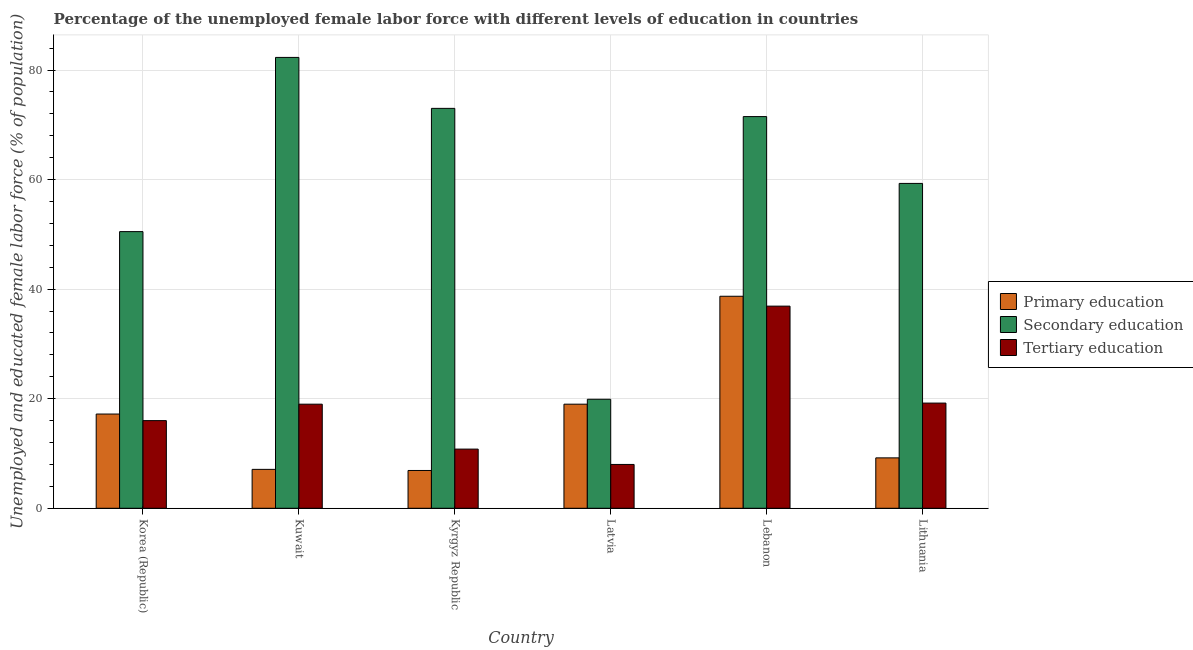How many different coloured bars are there?
Your answer should be compact. 3. Are the number of bars per tick equal to the number of legend labels?
Your answer should be very brief. Yes. How many bars are there on the 3rd tick from the right?
Provide a succinct answer. 3. What is the label of the 2nd group of bars from the left?
Ensure brevity in your answer.  Kuwait. In how many cases, is the number of bars for a given country not equal to the number of legend labels?
Your response must be concise. 0. What is the percentage of female labor force who received secondary education in Lebanon?
Ensure brevity in your answer.  71.5. Across all countries, what is the maximum percentage of female labor force who received primary education?
Your answer should be compact. 38.7. Across all countries, what is the minimum percentage of female labor force who received tertiary education?
Make the answer very short. 8. In which country was the percentage of female labor force who received primary education maximum?
Keep it short and to the point. Lebanon. In which country was the percentage of female labor force who received primary education minimum?
Your answer should be very brief. Kyrgyz Republic. What is the total percentage of female labor force who received tertiary education in the graph?
Provide a succinct answer. 109.9. What is the difference between the percentage of female labor force who received primary education in Kuwait and that in Kyrgyz Republic?
Your response must be concise. 0.2. What is the difference between the percentage of female labor force who received primary education in Lebanon and the percentage of female labor force who received tertiary education in Latvia?
Your answer should be very brief. 30.7. What is the average percentage of female labor force who received primary education per country?
Give a very brief answer. 16.35. What is the difference between the percentage of female labor force who received tertiary education and percentage of female labor force who received primary education in Kuwait?
Your answer should be compact. 11.9. What is the ratio of the percentage of female labor force who received secondary education in Kuwait to that in Lithuania?
Your answer should be very brief. 1.39. Is the difference between the percentage of female labor force who received primary education in Latvia and Lebanon greater than the difference between the percentage of female labor force who received tertiary education in Latvia and Lebanon?
Keep it short and to the point. Yes. What is the difference between the highest and the second highest percentage of female labor force who received primary education?
Provide a succinct answer. 19.7. What is the difference between the highest and the lowest percentage of female labor force who received tertiary education?
Make the answer very short. 28.9. What does the 3rd bar from the right in Kyrgyz Republic represents?
Offer a terse response. Primary education. Is it the case that in every country, the sum of the percentage of female labor force who received primary education and percentage of female labor force who received secondary education is greater than the percentage of female labor force who received tertiary education?
Make the answer very short. Yes. What is the difference between two consecutive major ticks on the Y-axis?
Offer a very short reply. 20. Are the values on the major ticks of Y-axis written in scientific E-notation?
Make the answer very short. No. Does the graph contain any zero values?
Your answer should be compact. No. Where does the legend appear in the graph?
Offer a very short reply. Center right. How many legend labels are there?
Offer a very short reply. 3. How are the legend labels stacked?
Give a very brief answer. Vertical. What is the title of the graph?
Provide a succinct answer. Percentage of the unemployed female labor force with different levels of education in countries. Does "Food" appear as one of the legend labels in the graph?
Offer a very short reply. No. What is the label or title of the Y-axis?
Ensure brevity in your answer.  Unemployed and educated female labor force (% of population). What is the Unemployed and educated female labor force (% of population) of Primary education in Korea (Republic)?
Your answer should be compact. 17.2. What is the Unemployed and educated female labor force (% of population) in Secondary education in Korea (Republic)?
Provide a short and direct response. 50.5. What is the Unemployed and educated female labor force (% of population) of Primary education in Kuwait?
Give a very brief answer. 7.1. What is the Unemployed and educated female labor force (% of population) in Secondary education in Kuwait?
Offer a terse response. 82.3. What is the Unemployed and educated female labor force (% of population) of Primary education in Kyrgyz Republic?
Offer a terse response. 6.9. What is the Unemployed and educated female labor force (% of population) of Tertiary education in Kyrgyz Republic?
Keep it short and to the point. 10.8. What is the Unemployed and educated female labor force (% of population) of Secondary education in Latvia?
Ensure brevity in your answer.  19.9. What is the Unemployed and educated female labor force (% of population) of Tertiary education in Latvia?
Offer a terse response. 8. What is the Unemployed and educated female labor force (% of population) in Primary education in Lebanon?
Provide a short and direct response. 38.7. What is the Unemployed and educated female labor force (% of population) of Secondary education in Lebanon?
Your response must be concise. 71.5. What is the Unemployed and educated female labor force (% of population) in Tertiary education in Lebanon?
Ensure brevity in your answer.  36.9. What is the Unemployed and educated female labor force (% of population) of Primary education in Lithuania?
Provide a succinct answer. 9.2. What is the Unemployed and educated female labor force (% of population) of Secondary education in Lithuania?
Provide a succinct answer. 59.3. What is the Unemployed and educated female labor force (% of population) of Tertiary education in Lithuania?
Ensure brevity in your answer.  19.2. Across all countries, what is the maximum Unemployed and educated female labor force (% of population) in Primary education?
Provide a short and direct response. 38.7. Across all countries, what is the maximum Unemployed and educated female labor force (% of population) of Secondary education?
Provide a succinct answer. 82.3. Across all countries, what is the maximum Unemployed and educated female labor force (% of population) of Tertiary education?
Ensure brevity in your answer.  36.9. Across all countries, what is the minimum Unemployed and educated female labor force (% of population) of Primary education?
Offer a terse response. 6.9. Across all countries, what is the minimum Unemployed and educated female labor force (% of population) of Secondary education?
Offer a terse response. 19.9. Across all countries, what is the minimum Unemployed and educated female labor force (% of population) in Tertiary education?
Your answer should be very brief. 8. What is the total Unemployed and educated female labor force (% of population) in Primary education in the graph?
Provide a short and direct response. 98.1. What is the total Unemployed and educated female labor force (% of population) of Secondary education in the graph?
Offer a very short reply. 356.5. What is the total Unemployed and educated female labor force (% of population) in Tertiary education in the graph?
Keep it short and to the point. 109.9. What is the difference between the Unemployed and educated female labor force (% of population) of Primary education in Korea (Republic) and that in Kuwait?
Your response must be concise. 10.1. What is the difference between the Unemployed and educated female labor force (% of population) in Secondary education in Korea (Republic) and that in Kuwait?
Provide a succinct answer. -31.8. What is the difference between the Unemployed and educated female labor force (% of population) in Primary education in Korea (Republic) and that in Kyrgyz Republic?
Make the answer very short. 10.3. What is the difference between the Unemployed and educated female labor force (% of population) of Secondary education in Korea (Republic) and that in Kyrgyz Republic?
Provide a succinct answer. -22.5. What is the difference between the Unemployed and educated female labor force (% of population) in Tertiary education in Korea (Republic) and that in Kyrgyz Republic?
Ensure brevity in your answer.  5.2. What is the difference between the Unemployed and educated female labor force (% of population) in Primary education in Korea (Republic) and that in Latvia?
Your answer should be compact. -1.8. What is the difference between the Unemployed and educated female labor force (% of population) of Secondary education in Korea (Republic) and that in Latvia?
Offer a very short reply. 30.6. What is the difference between the Unemployed and educated female labor force (% of population) of Tertiary education in Korea (Republic) and that in Latvia?
Make the answer very short. 8. What is the difference between the Unemployed and educated female labor force (% of population) in Primary education in Korea (Republic) and that in Lebanon?
Your answer should be compact. -21.5. What is the difference between the Unemployed and educated female labor force (% of population) in Secondary education in Korea (Republic) and that in Lebanon?
Your answer should be compact. -21. What is the difference between the Unemployed and educated female labor force (% of population) of Tertiary education in Korea (Republic) and that in Lebanon?
Offer a very short reply. -20.9. What is the difference between the Unemployed and educated female labor force (% of population) of Secondary education in Korea (Republic) and that in Lithuania?
Ensure brevity in your answer.  -8.8. What is the difference between the Unemployed and educated female labor force (% of population) in Tertiary education in Korea (Republic) and that in Lithuania?
Ensure brevity in your answer.  -3.2. What is the difference between the Unemployed and educated female labor force (% of population) in Tertiary education in Kuwait and that in Kyrgyz Republic?
Provide a succinct answer. 8.2. What is the difference between the Unemployed and educated female labor force (% of population) of Primary education in Kuwait and that in Latvia?
Offer a terse response. -11.9. What is the difference between the Unemployed and educated female labor force (% of population) of Secondary education in Kuwait and that in Latvia?
Offer a terse response. 62.4. What is the difference between the Unemployed and educated female labor force (% of population) of Tertiary education in Kuwait and that in Latvia?
Your answer should be very brief. 11. What is the difference between the Unemployed and educated female labor force (% of population) of Primary education in Kuwait and that in Lebanon?
Your response must be concise. -31.6. What is the difference between the Unemployed and educated female labor force (% of population) in Tertiary education in Kuwait and that in Lebanon?
Give a very brief answer. -17.9. What is the difference between the Unemployed and educated female labor force (% of population) in Primary education in Kuwait and that in Lithuania?
Provide a short and direct response. -2.1. What is the difference between the Unemployed and educated female labor force (% of population) in Secondary education in Kuwait and that in Lithuania?
Your answer should be very brief. 23. What is the difference between the Unemployed and educated female labor force (% of population) in Tertiary education in Kuwait and that in Lithuania?
Your response must be concise. -0.2. What is the difference between the Unemployed and educated female labor force (% of population) of Secondary education in Kyrgyz Republic and that in Latvia?
Ensure brevity in your answer.  53.1. What is the difference between the Unemployed and educated female labor force (% of population) of Tertiary education in Kyrgyz Republic and that in Latvia?
Ensure brevity in your answer.  2.8. What is the difference between the Unemployed and educated female labor force (% of population) in Primary education in Kyrgyz Republic and that in Lebanon?
Your answer should be very brief. -31.8. What is the difference between the Unemployed and educated female labor force (% of population) of Tertiary education in Kyrgyz Republic and that in Lebanon?
Your answer should be very brief. -26.1. What is the difference between the Unemployed and educated female labor force (% of population) of Tertiary education in Kyrgyz Republic and that in Lithuania?
Offer a very short reply. -8.4. What is the difference between the Unemployed and educated female labor force (% of population) of Primary education in Latvia and that in Lebanon?
Keep it short and to the point. -19.7. What is the difference between the Unemployed and educated female labor force (% of population) of Secondary education in Latvia and that in Lebanon?
Your answer should be compact. -51.6. What is the difference between the Unemployed and educated female labor force (% of population) of Tertiary education in Latvia and that in Lebanon?
Offer a very short reply. -28.9. What is the difference between the Unemployed and educated female labor force (% of population) in Primary education in Latvia and that in Lithuania?
Your answer should be very brief. 9.8. What is the difference between the Unemployed and educated female labor force (% of population) of Secondary education in Latvia and that in Lithuania?
Make the answer very short. -39.4. What is the difference between the Unemployed and educated female labor force (% of population) in Primary education in Lebanon and that in Lithuania?
Your answer should be very brief. 29.5. What is the difference between the Unemployed and educated female labor force (% of population) in Secondary education in Lebanon and that in Lithuania?
Offer a terse response. 12.2. What is the difference between the Unemployed and educated female labor force (% of population) in Primary education in Korea (Republic) and the Unemployed and educated female labor force (% of population) in Secondary education in Kuwait?
Offer a terse response. -65.1. What is the difference between the Unemployed and educated female labor force (% of population) in Primary education in Korea (Republic) and the Unemployed and educated female labor force (% of population) in Tertiary education in Kuwait?
Keep it short and to the point. -1.8. What is the difference between the Unemployed and educated female labor force (% of population) of Secondary education in Korea (Republic) and the Unemployed and educated female labor force (% of population) of Tertiary education in Kuwait?
Offer a terse response. 31.5. What is the difference between the Unemployed and educated female labor force (% of population) in Primary education in Korea (Republic) and the Unemployed and educated female labor force (% of population) in Secondary education in Kyrgyz Republic?
Offer a very short reply. -55.8. What is the difference between the Unemployed and educated female labor force (% of population) in Secondary education in Korea (Republic) and the Unemployed and educated female labor force (% of population) in Tertiary education in Kyrgyz Republic?
Keep it short and to the point. 39.7. What is the difference between the Unemployed and educated female labor force (% of population) of Primary education in Korea (Republic) and the Unemployed and educated female labor force (% of population) of Tertiary education in Latvia?
Your answer should be very brief. 9.2. What is the difference between the Unemployed and educated female labor force (% of population) of Secondary education in Korea (Republic) and the Unemployed and educated female labor force (% of population) of Tertiary education in Latvia?
Your answer should be very brief. 42.5. What is the difference between the Unemployed and educated female labor force (% of population) in Primary education in Korea (Republic) and the Unemployed and educated female labor force (% of population) in Secondary education in Lebanon?
Your answer should be compact. -54.3. What is the difference between the Unemployed and educated female labor force (% of population) in Primary education in Korea (Republic) and the Unemployed and educated female labor force (% of population) in Tertiary education in Lebanon?
Keep it short and to the point. -19.7. What is the difference between the Unemployed and educated female labor force (% of population) in Primary education in Korea (Republic) and the Unemployed and educated female labor force (% of population) in Secondary education in Lithuania?
Your answer should be compact. -42.1. What is the difference between the Unemployed and educated female labor force (% of population) of Primary education in Korea (Republic) and the Unemployed and educated female labor force (% of population) of Tertiary education in Lithuania?
Your answer should be very brief. -2. What is the difference between the Unemployed and educated female labor force (% of population) of Secondary education in Korea (Republic) and the Unemployed and educated female labor force (% of population) of Tertiary education in Lithuania?
Provide a succinct answer. 31.3. What is the difference between the Unemployed and educated female labor force (% of population) of Primary education in Kuwait and the Unemployed and educated female labor force (% of population) of Secondary education in Kyrgyz Republic?
Give a very brief answer. -65.9. What is the difference between the Unemployed and educated female labor force (% of population) in Secondary education in Kuwait and the Unemployed and educated female labor force (% of population) in Tertiary education in Kyrgyz Republic?
Ensure brevity in your answer.  71.5. What is the difference between the Unemployed and educated female labor force (% of population) of Primary education in Kuwait and the Unemployed and educated female labor force (% of population) of Secondary education in Latvia?
Offer a very short reply. -12.8. What is the difference between the Unemployed and educated female labor force (% of population) of Primary education in Kuwait and the Unemployed and educated female labor force (% of population) of Tertiary education in Latvia?
Make the answer very short. -0.9. What is the difference between the Unemployed and educated female labor force (% of population) of Secondary education in Kuwait and the Unemployed and educated female labor force (% of population) of Tertiary education in Latvia?
Your response must be concise. 74.3. What is the difference between the Unemployed and educated female labor force (% of population) of Primary education in Kuwait and the Unemployed and educated female labor force (% of population) of Secondary education in Lebanon?
Your answer should be compact. -64.4. What is the difference between the Unemployed and educated female labor force (% of population) of Primary education in Kuwait and the Unemployed and educated female labor force (% of population) of Tertiary education in Lebanon?
Provide a succinct answer. -29.8. What is the difference between the Unemployed and educated female labor force (% of population) in Secondary education in Kuwait and the Unemployed and educated female labor force (% of population) in Tertiary education in Lebanon?
Provide a short and direct response. 45.4. What is the difference between the Unemployed and educated female labor force (% of population) in Primary education in Kuwait and the Unemployed and educated female labor force (% of population) in Secondary education in Lithuania?
Offer a terse response. -52.2. What is the difference between the Unemployed and educated female labor force (% of population) of Secondary education in Kuwait and the Unemployed and educated female labor force (% of population) of Tertiary education in Lithuania?
Your answer should be very brief. 63.1. What is the difference between the Unemployed and educated female labor force (% of population) in Primary education in Kyrgyz Republic and the Unemployed and educated female labor force (% of population) in Secondary education in Latvia?
Offer a very short reply. -13. What is the difference between the Unemployed and educated female labor force (% of population) in Secondary education in Kyrgyz Republic and the Unemployed and educated female labor force (% of population) in Tertiary education in Latvia?
Offer a very short reply. 65. What is the difference between the Unemployed and educated female labor force (% of population) in Primary education in Kyrgyz Republic and the Unemployed and educated female labor force (% of population) in Secondary education in Lebanon?
Offer a very short reply. -64.6. What is the difference between the Unemployed and educated female labor force (% of population) in Primary education in Kyrgyz Republic and the Unemployed and educated female labor force (% of population) in Tertiary education in Lebanon?
Offer a very short reply. -30. What is the difference between the Unemployed and educated female labor force (% of population) in Secondary education in Kyrgyz Republic and the Unemployed and educated female labor force (% of population) in Tertiary education in Lebanon?
Your response must be concise. 36.1. What is the difference between the Unemployed and educated female labor force (% of population) in Primary education in Kyrgyz Republic and the Unemployed and educated female labor force (% of population) in Secondary education in Lithuania?
Make the answer very short. -52.4. What is the difference between the Unemployed and educated female labor force (% of population) of Primary education in Kyrgyz Republic and the Unemployed and educated female labor force (% of population) of Tertiary education in Lithuania?
Ensure brevity in your answer.  -12.3. What is the difference between the Unemployed and educated female labor force (% of population) of Secondary education in Kyrgyz Republic and the Unemployed and educated female labor force (% of population) of Tertiary education in Lithuania?
Offer a terse response. 53.8. What is the difference between the Unemployed and educated female labor force (% of population) in Primary education in Latvia and the Unemployed and educated female labor force (% of population) in Secondary education in Lebanon?
Give a very brief answer. -52.5. What is the difference between the Unemployed and educated female labor force (% of population) of Primary education in Latvia and the Unemployed and educated female labor force (% of population) of Tertiary education in Lebanon?
Offer a very short reply. -17.9. What is the difference between the Unemployed and educated female labor force (% of population) of Primary education in Latvia and the Unemployed and educated female labor force (% of population) of Secondary education in Lithuania?
Your answer should be compact. -40.3. What is the difference between the Unemployed and educated female labor force (% of population) of Secondary education in Latvia and the Unemployed and educated female labor force (% of population) of Tertiary education in Lithuania?
Offer a terse response. 0.7. What is the difference between the Unemployed and educated female labor force (% of population) of Primary education in Lebanon and the Unemployed and educated female labor force (% of population) of Secondary education in Lithuania?
Offer a very short reply. -20.6. What is the difference between the Unemployed and educated female labor force (% of population) of Primary education in Lebanon and the Unemployed and educated female labor force (% of population) of Tertiary education in Lithuania?
Provide a short and direct response. 19.5. What is the difference between the Unemployed and educated female labor force (% of population) of Secondary education in Lebanon and the Unemployed and educated female labor force (% of population) of Tertiary education in Lithuania?
Offer a very short reply. 52.3. What is the average Unemployed and educated female labor force (% of population) of Primary education per country?
Give a very brief answer. 16.35. What is the average Unemployed and educated female labor force (% of population) of Secondary education per country?
Your response must be concise. 59.42. What is the average Unemployed and educated female labor force (% of population) of Tertiary education per country?
Give a very brief answer. 18.32. What is the difference between the Unemployed and educated female labor force (% of population) of Primary education and Unemployed and educated female labor force (% of population) of Secondary education in Korea (Republic)?
Provide a short and direct response. -33.3. What is the difference between the Unemployed and educated female labor force (% of population) of Secondary education and Unemployed and educated female labor force (% of population) of Tertiary education in Korea (Republic)?
Give a very brief answer. 34.5. What is the difference between the Unemployed and educated female labor force (% of population) in Primary education and Unemployed and educated female labor force (% of population) in Secondary education in Kuwait?
Your answer should be compact. -75.2. What is the difference between the Unemployed and educated female labor force (% of population) in Primary education and Unemployed and educated female labor force (% of population) in Tertiary education in Kuwait?
Your answer should be compact. -11.9. What is the difference between the Unemployed and educated female labor force (% of population) of Secondary education and Unemployed and educated female labor force (% of population) of Tertiary education in Kuwait?
Your response must be concise. 63.3. What is the difference between the Unemployed and educated female labor force (% of population) of Primary education and Unemployed and educated female labor force (% of population) of Secondary education in Kyrgyz Republic?
Give a very brief answer. -66.1. What is the difference between the Unemployed and educated female labor force (% of population) in Secondary education and Unemployed and educated female labor force (% of population) in Tertiary education in Kyrgyz Republic?
Provide a succinct answer. 62.2. What is the difference between the Unemployed and educated female labor force (% of population) of Primary education and Unemployed and educated female labor force (% of population) of Secondary education in Lebanon?
Your answer should be compact. -32.8. What is the difference between the Unemployed and educated female labor force (% of population) of Primary education and Unemployed and educated female labor force (% of population) of Tertiary education in Lebanon?
Your answer should be compact. 1.8. What is the difference between the Unemployed and educated female labor force (% of population) of Secondary education and Unemployed and educated female labor force (% of population) of Tertiary education in Lebanon?
Make the answer very short. 34.6. What is the difference between the Unemployed and educated female labor force (% of population) of Primary education and Unemployed and educated female labor force (% of population) of Secondary education in Lithuania?
Give a very brief answer. -50.1. What is the difference between the Unemployed and educated female labor force (% of population) of Primary education and Unemployed and educated female labor force (% of population) of Tertiary education in Lithuania?
Provide a succinct answer. -10. What is the difference between the Unemployed and educated female labor force (% of population) of Secondary education and Unemployed and educated female labor force (% of population) of Tertiary education in Lithuania?
Your answer should be very brief. 40.1. What is the ratio of the Unemployed and educated female labor force (% of population) of Primary education in Korea (Republic) to that in Kuwait?
Provide a succinct answer. 2.42. What is the ratio of the Unemployed and educated female labor force (% of population) of Secondary education in Korea (Republic) to that in Kuwait?
Ensure brevity in your answer.  0.61. What is the ratio of the Unemployed and educated female labor force (% of population) of Tertiary education in Korea (Republic) to that in Kuwait?
Give a very brief answer. 0.84. What is the ratio of the Unemployed and educated female labor force (% of population) in Primary education in Korea (Republic) to that in Kyrgyz Republic?
Make the answer very short. 2.49. What is the ratio of the Unemployed and educated female labor force (% of population) in Secondary education in Korea (Republic) to that in Kyrgyz Republic?
Keep it short and to the point. 0.69. What is the ratio of the Unemployed and educated female labor force (% of population) of Tertiary education in Korea (Republic) to that in Kyrgyz Republic?
Offer a terse response. 1.48. What is the ratio of the Unemployed and educated female labor force (% of population) of Primary education in Korea (Republic) to that in Latvia?
Provide a succinct answer. 0.91. What is the ratio of the Unemployed and educated female labor force (% of population) in Secondary education in Korea (Republic) to that in Latvia?
Provide a short and direct response. 2.54. What is the ratio of the Unemployed and educated female labor force (% of population) in Tertiary education in Korea (Republic) to that in Latvia?
Your answer should be very brief. 2. What is the ratio of the Unemployed and educated female labor force (% of population) in Primary education in Korea (Republic) to that in Lebanon?
Ensure brevity in your answer.  0.44. What is the ratio of the Unemployed and educated female labor force (% of population) in Secondary education in Korea (Republic) to that in Lebanon?
Give a very brief answer. 0.71. What is the ratio of the Unemployed and educated female labor force (% of population) of Tertiary education in Korea (Republic) to that in Lebanon?
Your answer should be very brief. 0.43. What is the ratio of the Unemployed and educated female labor force (% of population) in Primary education in Korea (Republic) to that in Lithuania?
Your response must be concise. 1.87. What is the ratio of the Unemployed and educated female labor force (% of population) of Secondary education in Korea (Republic) to that in Lithuania?
Give a very brief answer. 0.85. What is the ratio of the Unemployed and educated female labor force (% of population) in Tertiary education in Korea (Republic) to that in Lithuania?
Make the answer very short. 0.83. What is the ratio of the Unemployed and educated female labor force (% of population) in Secondary education in Kuwait to that in Kyrgyz Republic?
Keep it short and to the point. 1.13. What is the ratio of the Unemployed and educated female labor force (% of population) in Tertiary education in Kuwait to that in Kyrgyz Republic?
Your response must be concise. 1.76. What is the ratio of the Unemployed and educated female labor force (% of population) of Primary education in Kuwait to that in Latvia?
Offer a terse response. 0.37. What is the ratio of the Unemployed and educated female labor force (% of population) of Secondary education in Kuwait to that in Latvia?
Offer a terse response. 4.14. What is the ratio of the Unemployed and educated female labor force (% of population) in Tertiary education in Kuwait to that in Latvia?
Keep it short and to the point. 2.38. What is the ratio of the Unemployed and educated female labor force (% of population) of Primary education in Kuwait to that in Lebanon?
Your answer should be compact. 0.18. What is the ratio of the Unemployed and educated female labor force (% of population) of Secondary education in Kuwait to that in Lebanon?
Your response must be concise. 1.15. What is the ratio of the Unemployed and educated female labor force (% of population) in Tertiary education in Kuwait to that in Lebanon?
Provide a succinct answer. 0.51. What is the ratio of the Unemployed and educated female labor force (% of population) of Primary education in Kuwait to that in Lithuania?
Your answer should be very brief. 0.77. What is the ratio of the Unemployed and educated female labor force (% of population) in Secondary education in Kuwait to that in Lithuania?
Give a very brief answer. 1.39. What is the ratio of the Unemployed and educated female labor force (% of population) of Tertiary education in Kuwait to that in Lithuania?
Your answer should be very brief. 0.99. What is the ratio of the Unemployed and educated female labor force (% of population) in Primary education in Kyrgyz Republic to that in Latvia?
Offer a terse response. 0.36. What is the ratio of the Unemployed and educated female labor force (% of population) in Secondary education in Kyrgyz Republic to that in Latvia?
Make the answer very short. 3.67. What is the ratio of the Unemployed and educated female labor force (% of population) in Tertiary education in Kyrgyz Republic to that in Latvia?
Provide a short and direct response. 1.35. What is the ratio of the Unemployed and educated female labor force (% of population) in Primary education in Kyrgyz Republic to that in Lebanon?
Offer a very short reply. 0.18. What is the ratio of the Unemployed and educated female labor force (% of population) of Secondary education in Kyrgyz Republic to that in Lebanon?
Your answer should be very brief. 1.02. What is the ratio of the Unemployed and educated female labor force (% of population) of Tertiary education in Kyrgyz Republic to that in Lebanon?
Ensure brevity in your answer.  0.29. What is the ratio of the Unemployed and educated female labor force (% of population) in Primary education in Kyrgyz Republic to that in Lithuania?
Ensure brevity in your answer.  0.75. What is the ratio of the Unemployed and educated female labor force (% of population) in Secondary education in Kyrgyz Republic to that in Lithuania?
Provide a succinct answer. 1.23. What is the ratio of the Unemployed and educated female labor force (% of population) in Tertiary education in Kyrgyz Republic to that in Lithuania?
Provide a succinct answer. 0.56. What is the ratio of the Unemployed and educated female labor force (% of population) of Primary education in Latvia to that in Lebanon?
Give a very brief answer. 0.49. What is the ratio of the Unemployed and educated female labor force (% of population) of Secondary education in Latvia to that in Lebanon?
Make the answer very short. 0.28. What is the ratio of the Unemployed and educated female labor force (% of population) of Tertiary education in Latvia to that in Lebanon?
Provide a short and direct response. 0.22. What is the ratio of the Unemployed and educated female labor force (% of population) of Primary education in Latvia to that in Lithuania?
Provide a short and direct response. 2.07. What is the ratio of the Unemployed and educated female labor force (% of population) in Secondary education in Latvia to that in Lithuania?
Offer a very short reply. 0.34. What is the ratio of the Unemployed and educated female labor force (% of population) in Tertiary education in Latvia to that in Lithuania?
Give a very brief answer. 0.42. What is the ratio of the Unemployed and educated female labor force (% of population) in Primary education in Lebanon to that in Lithuania?
Offer a terse response. 4.21. What is the ratio of the Unemployed and educated female labor force (% of population) in Secondary education in Lebanon to that in Lithuania?
Your answer should be very brief. 1.21. What is the ratio of the Unemployed and educated female labor force (% of population) in Tertiary education in Lebanon to that in Lithuania?
Give a very brief answer. 1.92. What is the difference between the highest and the lowest Unemployed and educated female labor force (% of population) of Primary education?
Ensure brevity in your answer.  31.8. What is the difference between the highest and the lowest Unemployed and educated female labor force (% of population) of Secondary education?
Provide a short and direct response. 62.4. What is the difference between the highest and the lowest Unemployed and educated female labor force (% of population) of Tertiary education?
Ensure brevity in your answer.  28.9. 